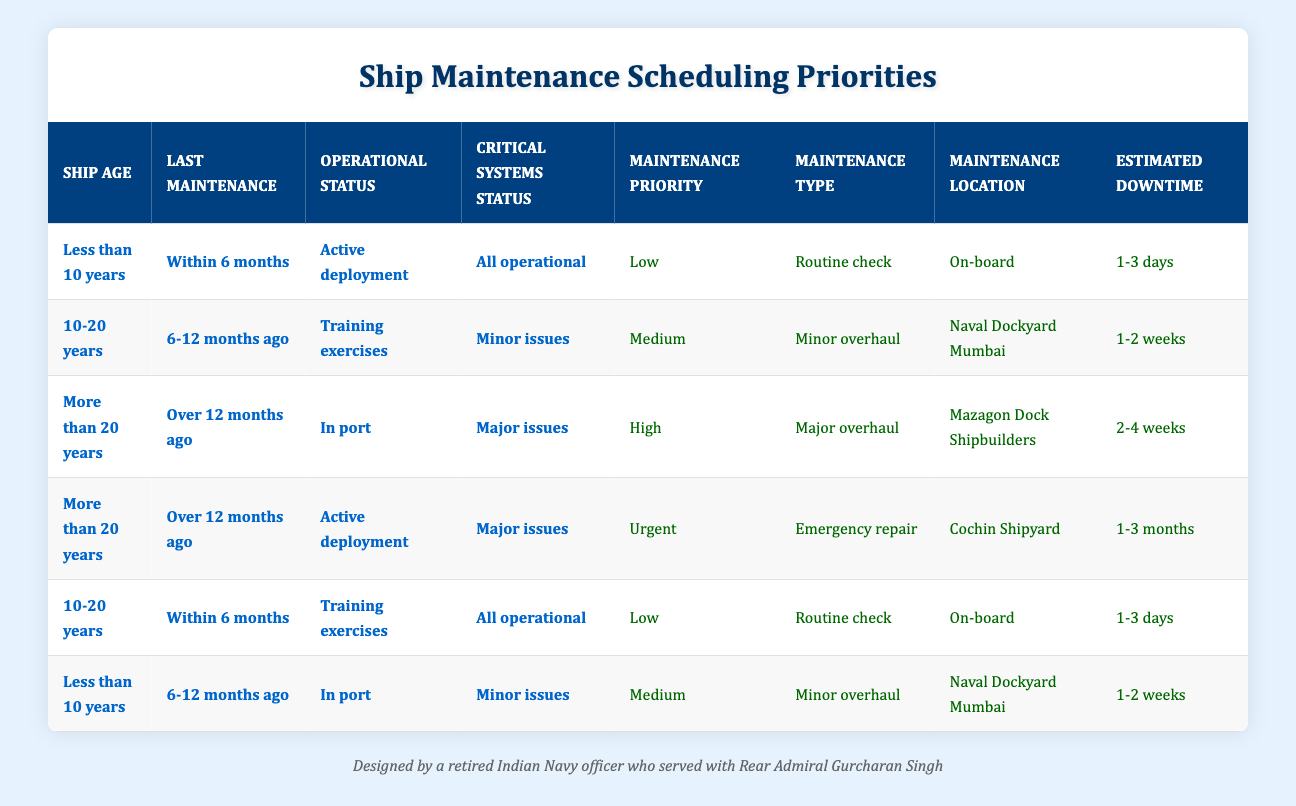What is the maintenance priority for ships that are older than 20 years and have major issues? The table has a row meeting these criteria: "More than 20 years," "Over 12 months ago," "Active deployment," and "Major issues." The maintenance priority for this scenario is "Urgent."
Answer: Urgent How many types of maintenance are scheduled for ships in training exercises that are 10-20 years old? The table shows one entry with the conditions "10-20 years," "6-12 months ago," "Training exercises," and "Minor issues," resulting in "Medium" priority and "Minor overhaul." Thus, there is one type of maintenance scheduled in this instance.
Answer: 1 Is it true that routine checks are only assigned to ships less than 10 years old? The table shows two rows with "Routine check." One is for a ship less than 10 years old, and the other is for a ship aged 10-20 years in training exercises. Therefore, the statement is false as routine checks also apply to 10-20 years old ships.
Answer: No What is the estimated downtime for a ship that has not had maintenance in over 12 months and has minor issues? A ship that meets these criteria is "Less than 10 years," "6-12 months ago," "In port," and "Minor issues," which has an estimated downtime of "1-2 weeks" according to the table.
Answer: 1-2 weeks How many ships require urgent maintenance and what is the type of maintenance needed? The table identifies one instance of urgent maintenance: "More than 20 years," "Over 12 months ago," "Active deployment," and "Major issues." The type of maintenance needed is "Emergency repair." Since only one rules exist for urgent maintenance, the count is one.
Answer: 1, Emergency repair What is the maintenance type for ships between 10-20 years old that have been maintained within the last 6 months? The table presents a specific entry with the conditions matching this profile: "10-20 years," "Within 6 months," "Training exercises," and "All operational," resulting in a "Routine check."
Answer: Routine check In what locations are maintenance actions performed for ships older than 20 years with major issues? There are two entries for this condition in the table: one specifies "Mazagon Dock Shipbuilders" for "In port" status with high priority and another "Cochin Shipyard" for urgent emergency repair when active.
Answer: Mazagon Dock Shipbuilders, Cochin Shipyard What are the possible estimated downtimes for ships in active deployment that are more than 20 years old? Upon analyzing the table, one row indicates "1-3 months" for ships with major issues in active deployment and another entry reveals "2-4 weeks" for those in port, respectively. Thus, two distinct estimated downtimes are present: "1-3 months" and "2-4 weeks."
Answer: 1-3 months, 2-4 weeks 